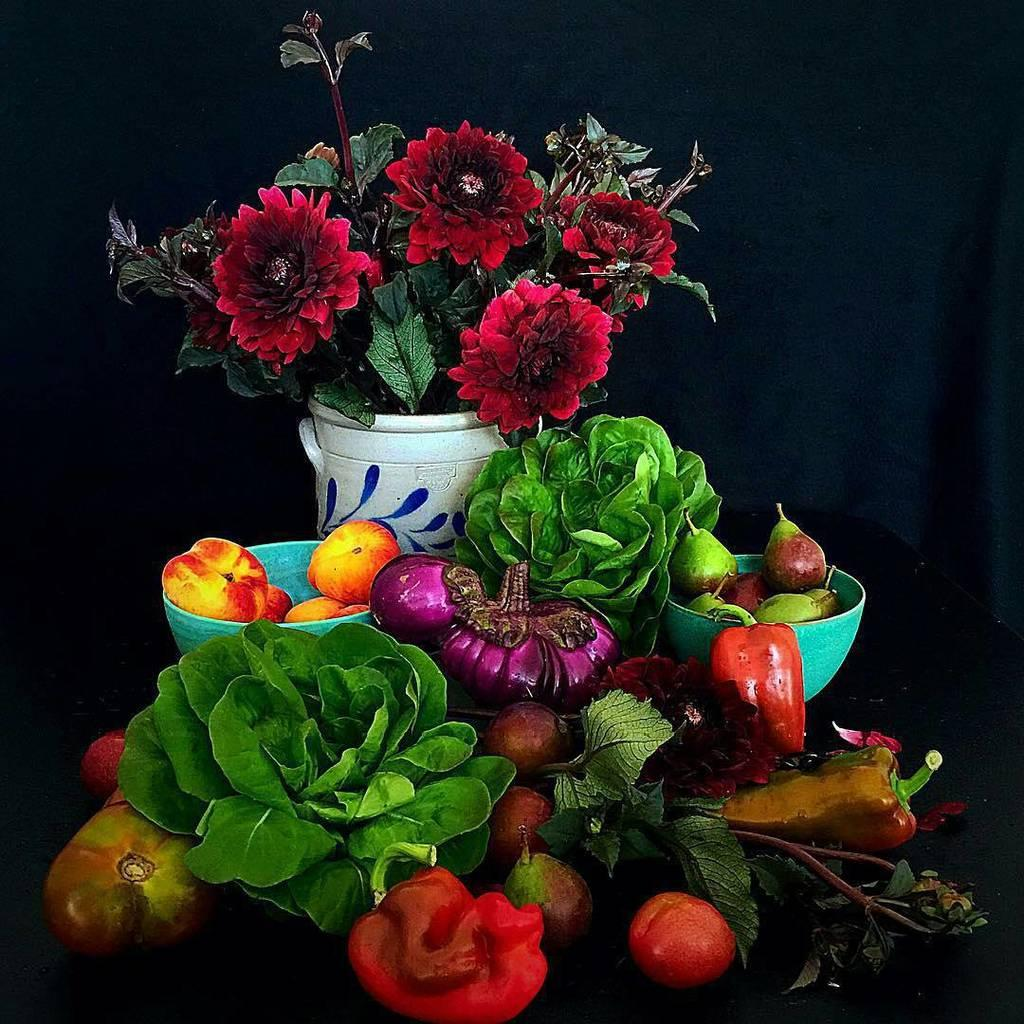What types of plants are visible in the image? There are flowers in the image. What other types of food items can be seen in the image? There are fruits and vegetables in the image. What color is the background of the image? The background of the image is black. What type of tin can be seen in the image? There is no tin present in the image. How does the wall contribute to the overall composition of the image? There is no wall present in the image, so it cannot contribute to the composition. 